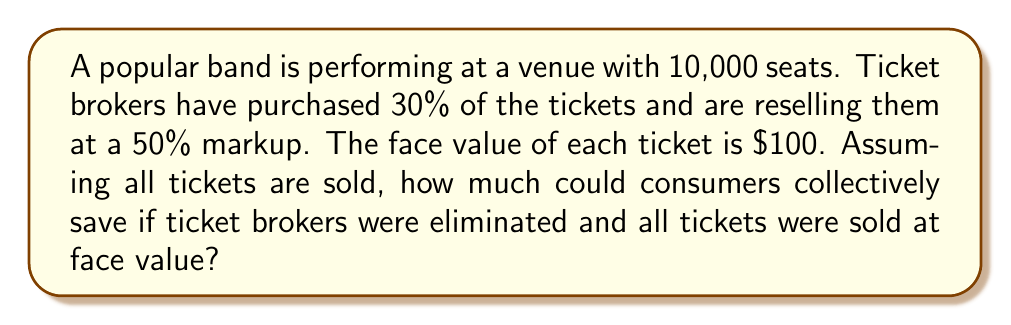Provide a solution to this math problem. Let's break this problem down step-by-step:

1. Calculate the number of tickets purchased by brokers:
   $$ 30\% \text{ of } 10,000 = 0.30 \times 10,000 = 3,000 \text{ tickets} $$

2. Calculate the broker's selling price per ticket:
   $$ \text{Broker price} = \text{Face value} + 50\% \text{ markup} $$
   $$ \text{Broker price} = \$100 + (0.50 \times \$100) = \$150 $$

3. Calculate the difference between broker price and face value:
   $$ \text{Price difference} = \$150 - \$100 = \$50 \text{ per ticket} $$

4. Calculate the total savings if brokers were eliminated:
   $$ \text{Total savings} = \text{Number of broker tickets} \times \text{Price difference} $$
   $$ \text{Total savings} = 3,000 \times \$50 = \$150,000 $$

Therefore, if ticket brokers were eliminated and all tickets were sold at face value, consumers could collectively save $150,000.
Answer: $150,000 